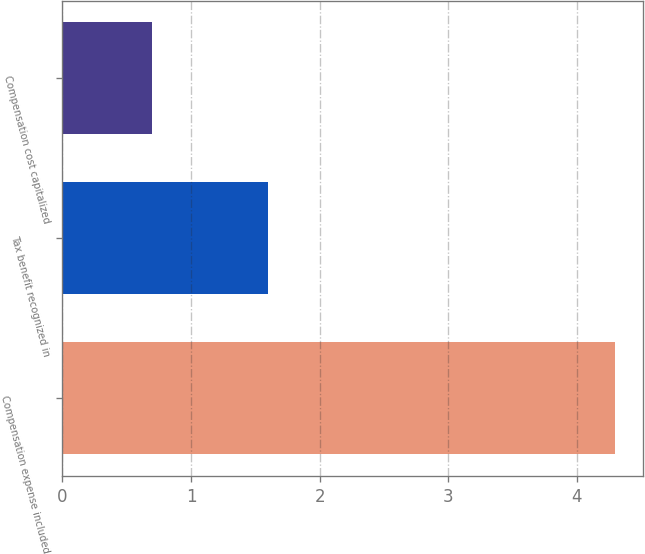Convert chart. <chart><loc_0><loc_0><loc_500><loc_500><bar_chart><fcel>Compensation expense included<fcel>Tax benefit recognized in<fcel>Compensation cost capitalized<nl><fcel>4.3<fcel>1.6<fcel>0.7<nl></chart> 